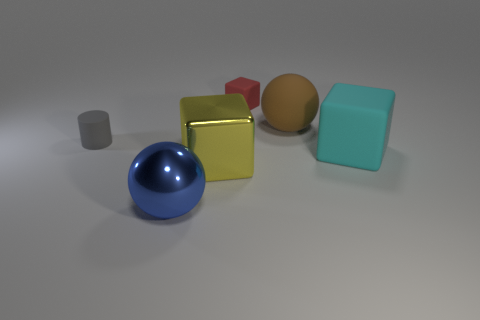Add 2 tiny cubes. How many objects exist? 8 Subtract all cylinders. How many objects are left? 5 Add 6 small red blocks. How many small red blocks are left? 7 Add 2 tiny purple objects. How many tiny purple objects exist? 2 Subtract 0 green balls. How many objects are left? 6 Subtract all cyan things. Subtract all small red matte blocks. How many objects are left? 4 